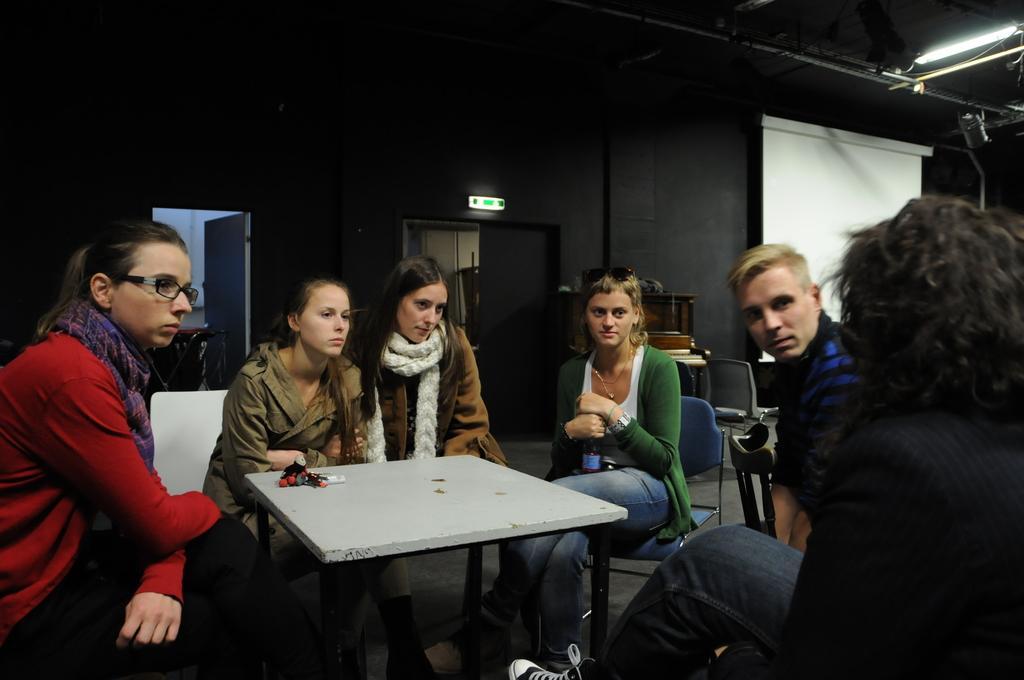How would you summarize this image in a sentence or two? The picture is taken in a closed room in which six people are sitting on their chairs and between them there is a table and behind the people there is a big wall with two doors and one big screen is present and in the middle of the picture one woman is wearing a green coat and holding a bottle, behind her there is a wooden wardrobe is present. 